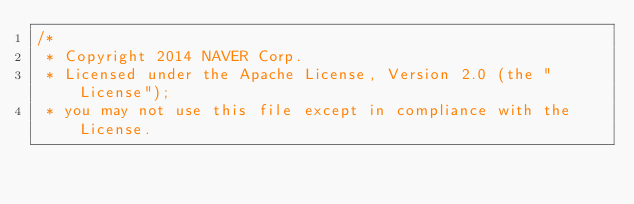<code> <loc_0><loc_0><loc_500><loc_500><_Java_>/*
 * Copyright 2014 NAVER Corp.
 * Licensed under the Apache License, Version 2.0 (the "License");
 * you may not use this file except in compliance with the License.</code> 